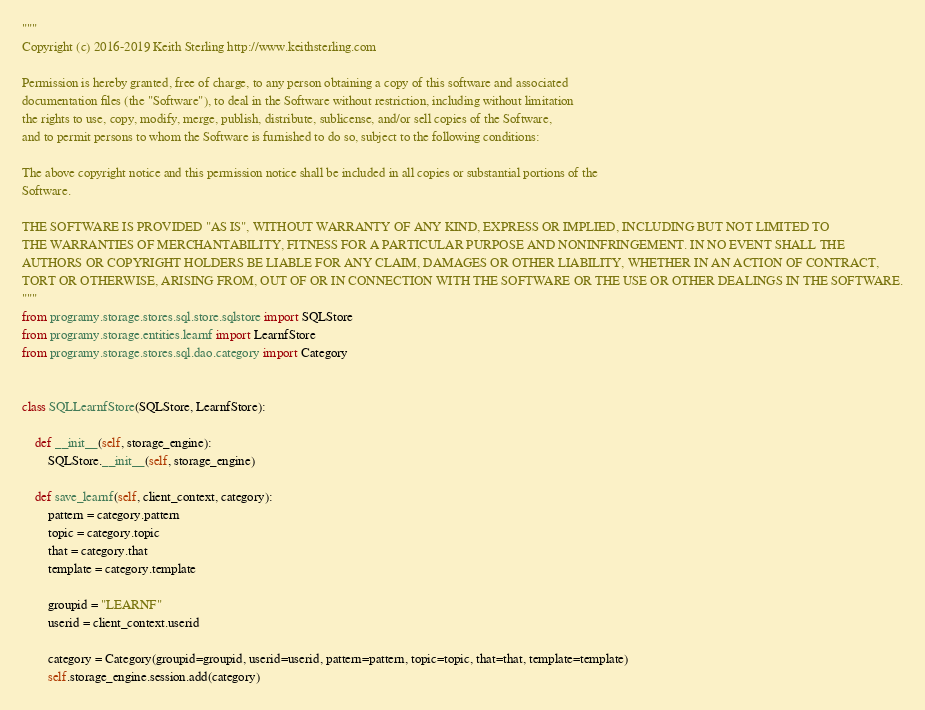Convert code to text. <code><loc_0><loc_0><loc_500><loc_500><_Python_>"""
Copyright (c) 2016-2019 Keith Sterling http://www.keithsterling.com

Permission is hereby granted, free of charge, to any person obtaining a copy of this software and associated
documentation files (the "Software"), to deal in the Software without restriction, including without limitation
the rights to use, copy, modify, merge, publish, distribute, sublicense, and/or sell copies of the Software,
and to permit persons to whom the Software is furnished to do so, subject to the following conditions:

The above copyright notice and this permission notice shall be included in all copies or substantial portions of the
Software.

THE SOFTWARE IS PROVIDED "AS IS", WITHOUT WARRANTY OF ANY KIND, EXPRESS OR IMPLIED, INCLUDING BUT NOT LIMITED TO
THE WARRANTIES OF MERCHANTABILITY, FITNESS FOR A PARTICULAR PURPOSE AND NONINFRINGEMENT. IN NO EVENT SHALL THE
AUTHORS OR COPYRIGHT HOLDERS BE LIABLE FOR ANY CLAIM, DAMAGES OR OTHER LIABILITY, WHETHER IN AN ACTION OF CONTRACT,
TORT OR OTHERWISE, ARISING FROM, OUT OF OR IN CONNECTION WITH THE SOFTWARE OR THE USE OR OTHER DEALINGS IN THE SOFTWARE.
"""
from programy.storage.stores.sql.store.sqlstore import SQLStore
from programy.storage.entities.learnf import LearnfStore
from programy.storage.stores.sql.dao.category import Category


class SQLLearnfStore(SQLStore, LearnfStore):

    def __init__(self, storage_engine):
        SQLStore.__init__(self, storage_engine)

    def save_learnf(self, client_context, category):
        pattern = category.pattern
        topic = category.topic
        that = category.that
        template = category.template

        groupid = "LEARNF"
        userid = client_context.userid

        category = Category(groupid=groupid, userid=userid, pattern=pattern, topic=topic, that=that, template=template)
        self.storage_engine.session.add(category)
</code> 